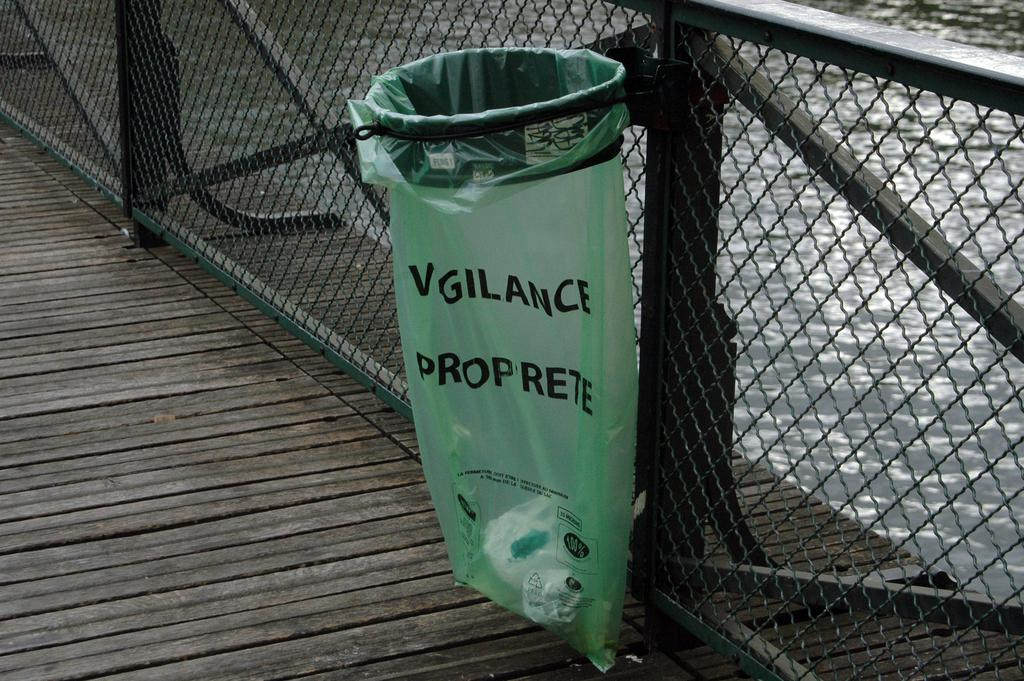<image>
Create a compact narrative representing the image presented. A green trashbag that has VIGILANCE PROPRETE on it. 